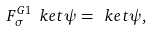<formula> <loc_0><loc_0><loc_500><loc_500>F ^ { G 1 } _ { \sigma } \ k e t \psi = \ k e t \psi ,</formula> 